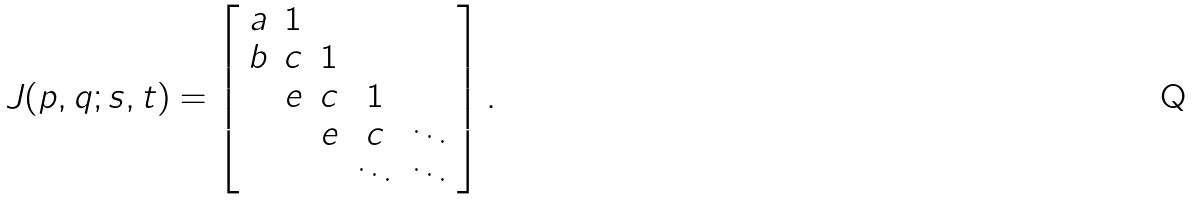Convert formula to latex. <formula><loc_0><loc_0><loc_500><loc_500>J ( p , q ; s , t ) = \left [ \begin{array} { c c c c c } a & 1 & & & \\ b & c & 1 & \\ & e & c & 1 & \\ & & e & c & \ddots \\ & & & \ddots & \ddots \\ \end{array} \right ] .</formula> 